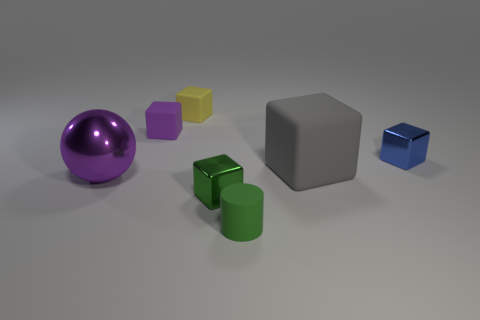There is a cube that is the same size as the metal sphere; what color is it?
Offer a terse response. Gray. There is a tiny metallic thing in front of the gray matte block; what number of green blocks are on the right side of it?
Offer a terse response. 0. How many shiny things are both behind the green shiny block and on the right side of the purple shiny thing?
Keep it short and to the point. 1. What number of things are either tiny blocks left of the blue block or purple metal objects that are to the left of the tiny yellow object?
Give a very brief answer. 4. How many other objects are there of the same size as the shiny sphere?
Your answer should be compact. 1. The tiny shiny object that is behind the shiny thing to the left of the yellow matte block is what shape?
Keep it short and to the point. Cube. There is a tiny matte thing that is in front of the tiny green block; is it the same color as the metallic block in front of the gray matte object?
Your answer should be very brief. Yes. Is there anything else that is the same color as the large shiny sphere?
Your response must be concise. Yes. The big shiny object is what color?
Provide a succinct answer. Purple. Are there any small red metallic things?
Keep it short and to the point. No. 